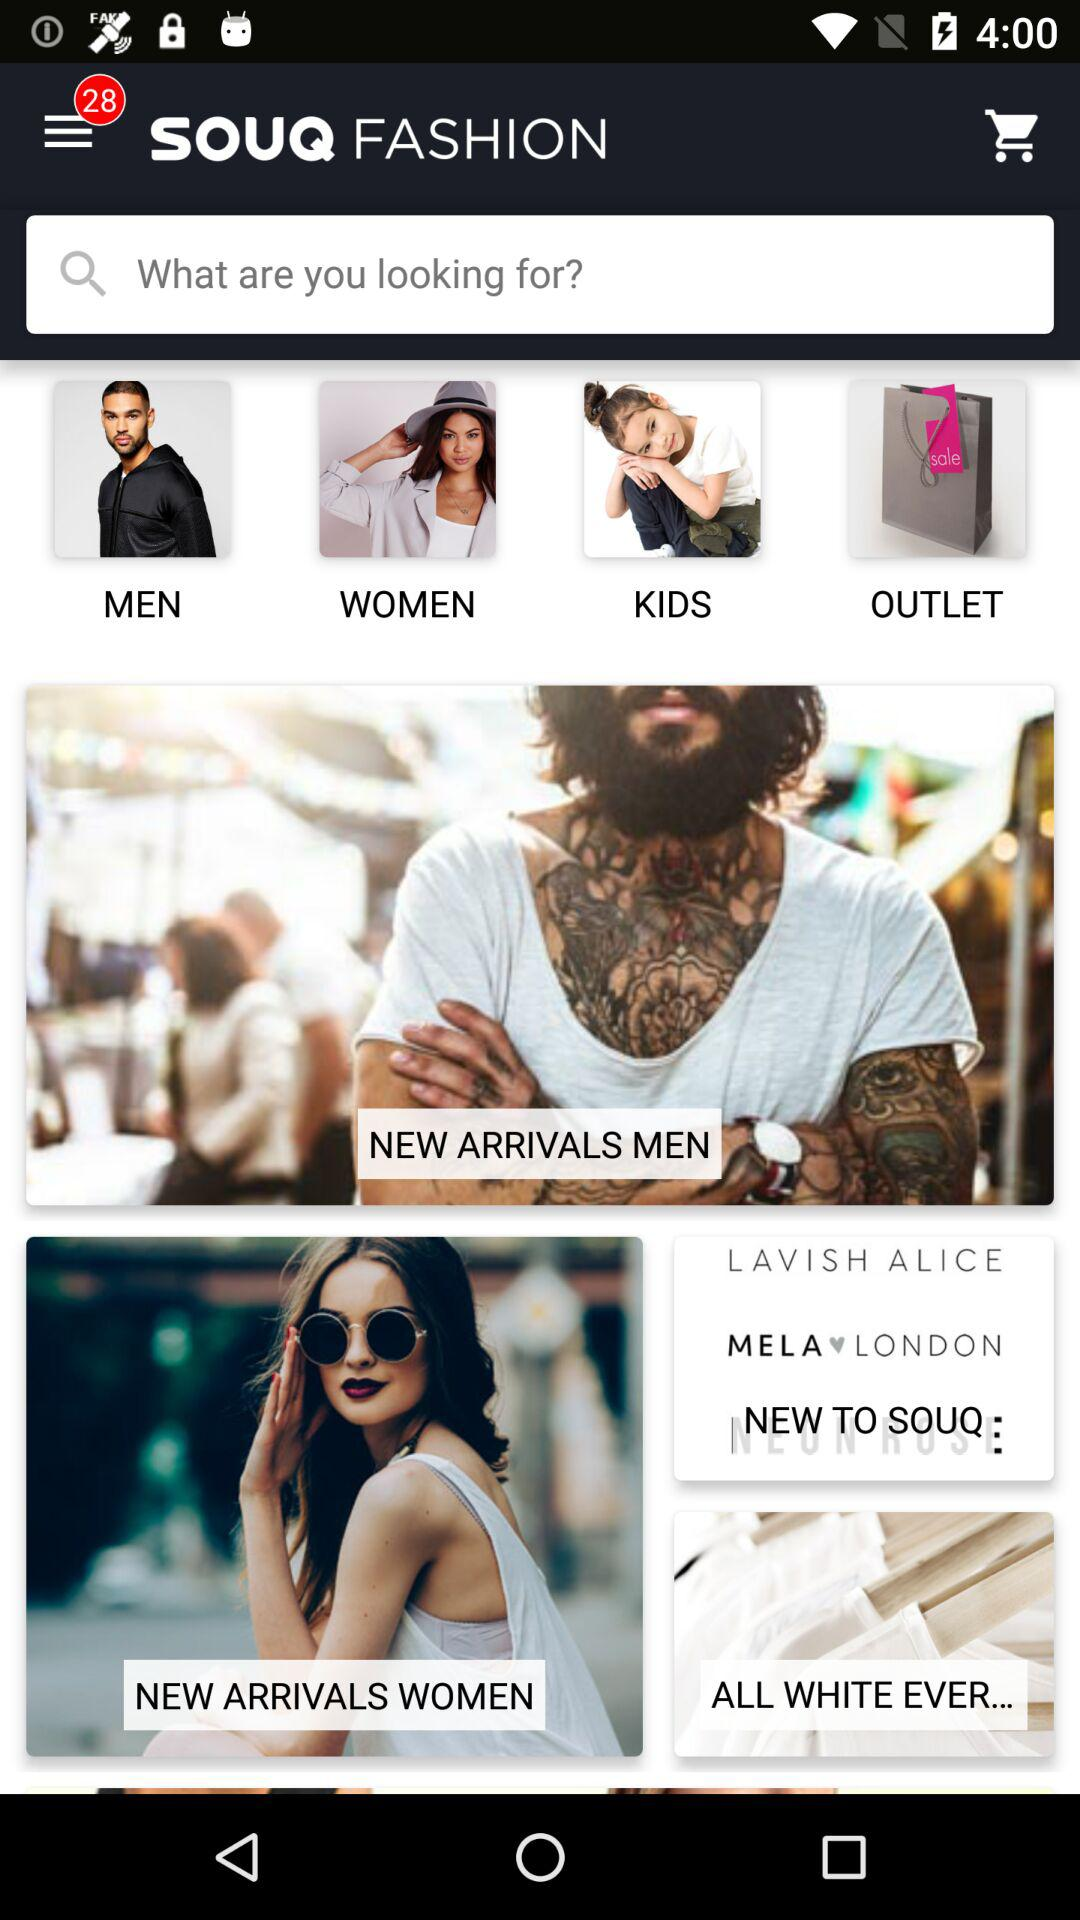How many new notifications are there? There are 28 new notifications. 